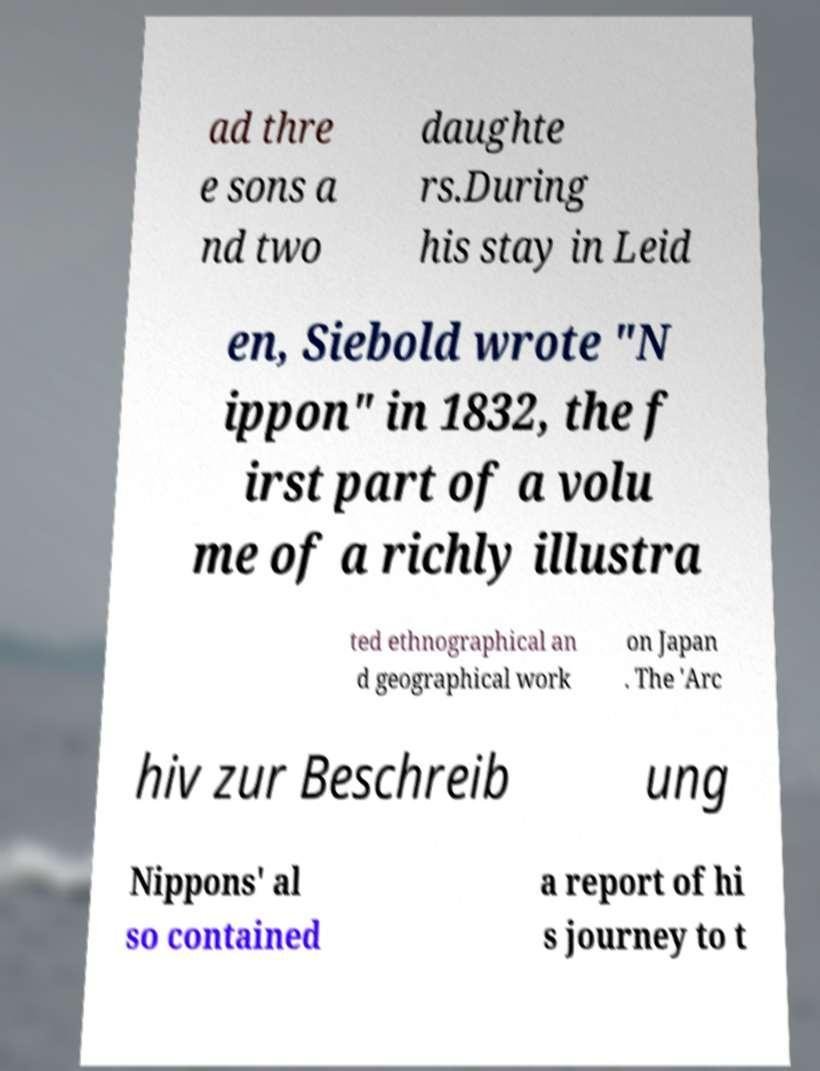Please identify and transcribe the text found in this image. ad thre e sons a nd two daughte rs.During his stay in Leid en, Siebold wrote "N ippon" in 1832, the f irst part of a volu me of a richly illustra ted ethnographical an d geographical work on Japan . The 'Arc hiv zur Beschreib ung Nippons' al so contained a report of hi s journey to t 